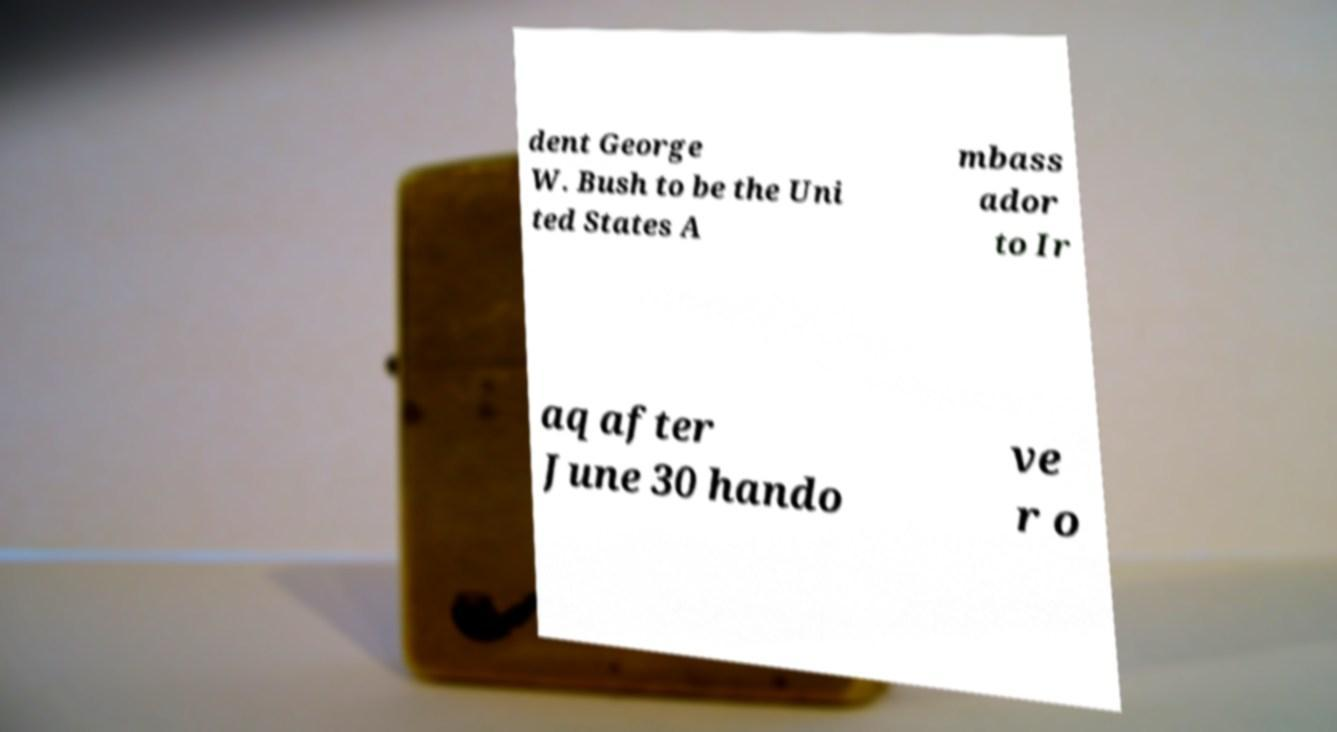Can you accurately transcribe the text from the provided image for me? dent George W. Bush to be the Uni ted States A mbass ador to Ir aq after June 30 hando ve r o 